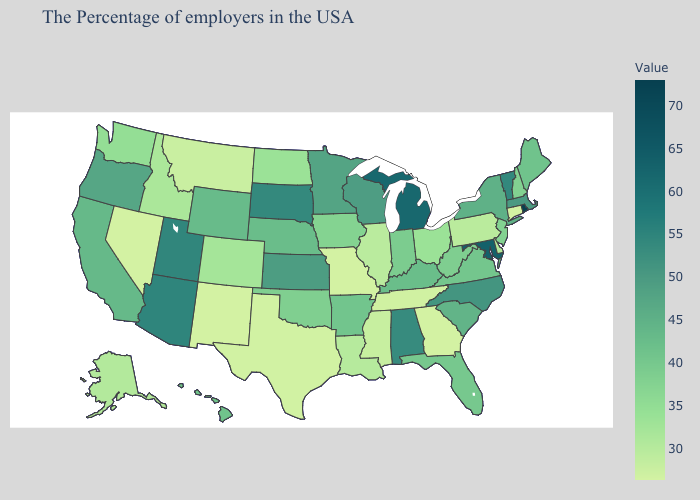Does Pennsylvania have the highest value in the Northeast?
Write a very short answer. No. Does New York have a higher value than Maryland?
Short answer required. No. Does the map have missing data?
Concise answer only. No. Among the states that border Arkansas , which have the lowest value?
Short answer required. Missouri. Among the states that border Minnesota , does Iowa have the highest value?
Keep it brief. No. 